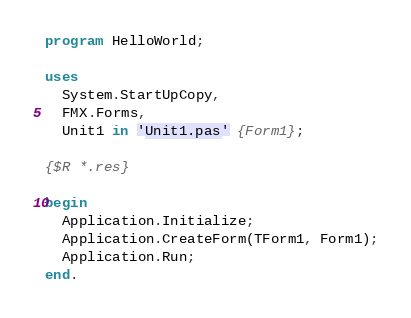Convert code to text. <code><loc_0><loc_0><loc_500><loc_500><_Pascal_>program HelloWorld;

uses
  System.StartUpCopy,
  FMX.Forms,
  Unit1 in 'Unit1.pas' {Form1};

{$R *.res}

begin
  Application.Initialize;
  Application.CreateForm(TForm1, Form1);
  Application.Run;
end.
</code> 